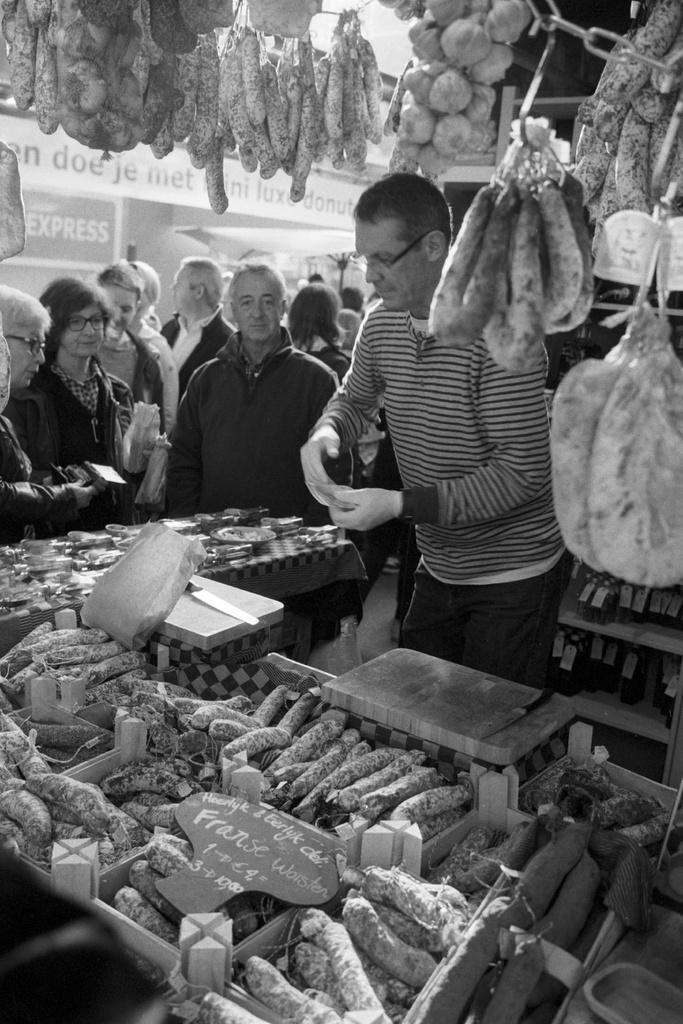How many people are in the image? There is a group of persons standing in the image. What is present in the image besides the group of persons? There is a table in the image. What can be found on the table? There are food items on the table. What type of soup is being served in the image? There is no soup present in the image; only a group of persons and a table with food items are visible. 